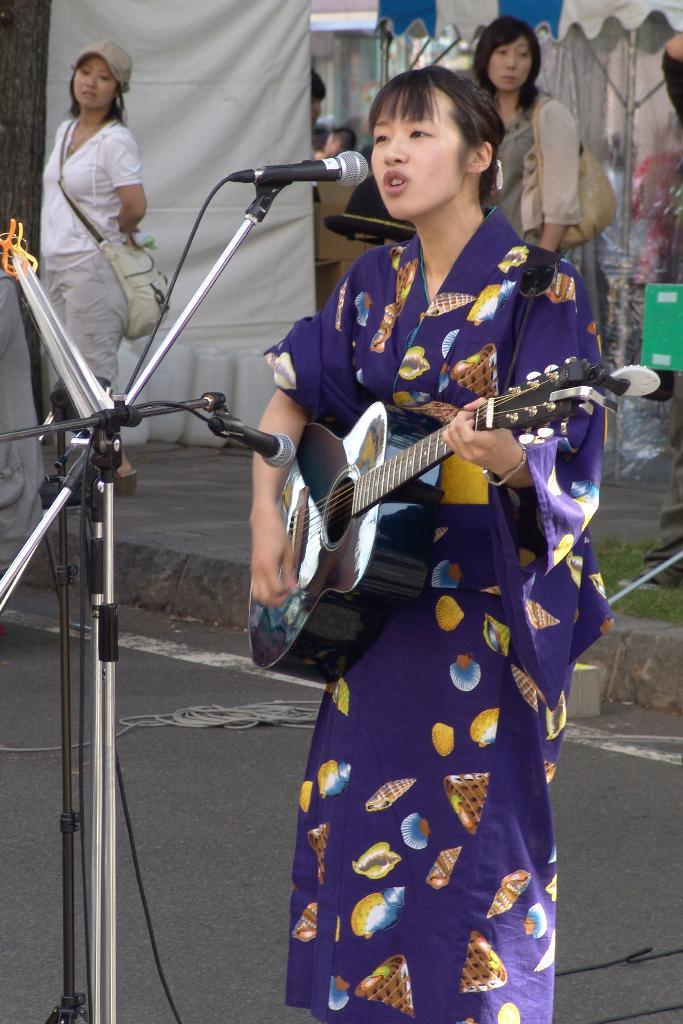What is the woman in the image holding? The woman is holding a guitar in the image. What is the woman doing with the guitar? The woman is singing into a microphone while holding the guitar. Can you describe the background of the image? The background includes a tent and a curtain. Are there any other people visible in the image? Yes, there are two women standing in the background. What direction is the woman facing in the image? The direction the woman is facing cannot be determined from the image alone, as there is no reference point for direction. 